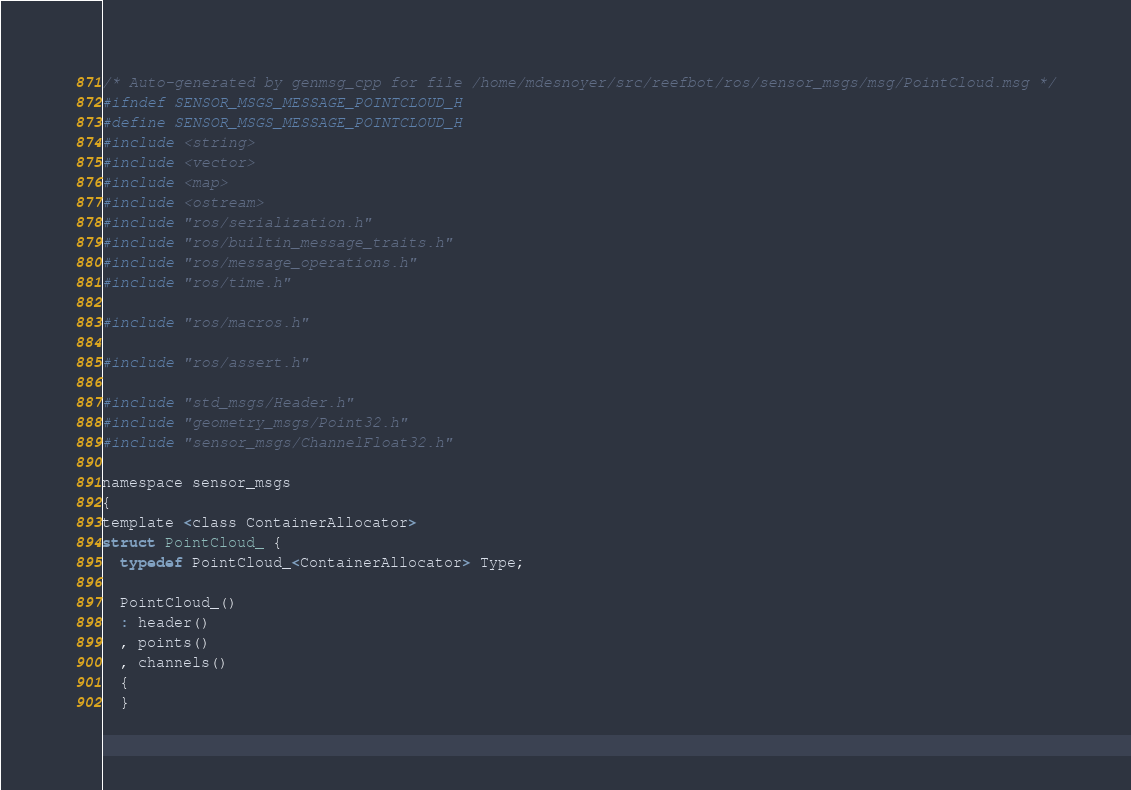Convert code to text. <code><loc_0><loc_0><loc_500><loc_500><_C_>/* Auto-generated by genmsg_cpp for file /home/mdesnoyer/src/reefbot/ros/sensor_msgs/msg/PointCloud.msg */
#ifndef SENSOR_MSGS_MESSAGE_POINTCLOUD_H
#define SENSOR_MSGS_MESSAGE_POINTCLOUD_H
#include <string>
#include <vector>
#include <map>
#include <ostream>
#include "ros/serialization.h"
#include "ros/builtin_message_traits.h"
#include "ros/message_operations.h"
#include "ros/time.h"

#include "ros/macros.h"

#include "ros/assert.h"

#include "std_msgs/Header.h"
#include "geometry_msgs/Point32.h"
#include "sensor_msgs/ChannelFloat32.h"

namespace sensor_msgs
{
template <class ContainerAllocator>
struct PointCloud_ {
  typedef PointCloud_<ContainerAllocator> Type;

  PointCloud_()
  : header()
  , points()
  , channels()
  {
  }
</code> 